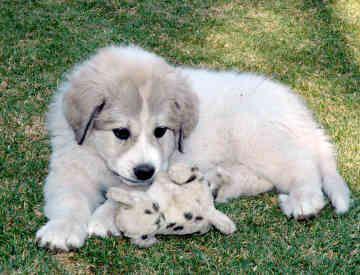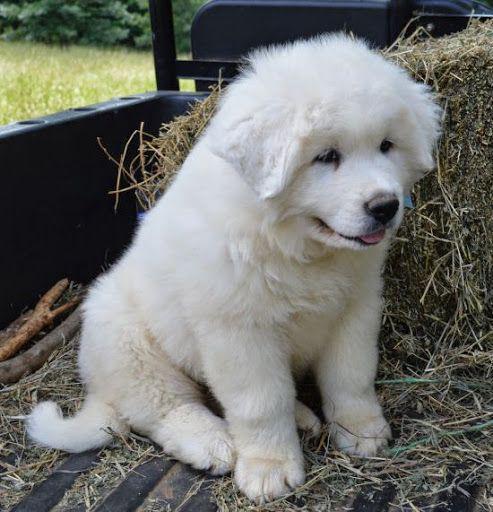The first image is the image on the left, the second image is the image on the right. Analyze the images presented: Is the assertion "One image shows an adult white dog standing on all fours in a grassy area." valid? Answer yes or no. No. The first image is the image on the left, the second image is the image on the right. Evaluate the accuracy of this statement regarding the images: "A single white dog is laying on the grass in the image on the right.". Is it true? Answer yes or no. No. 